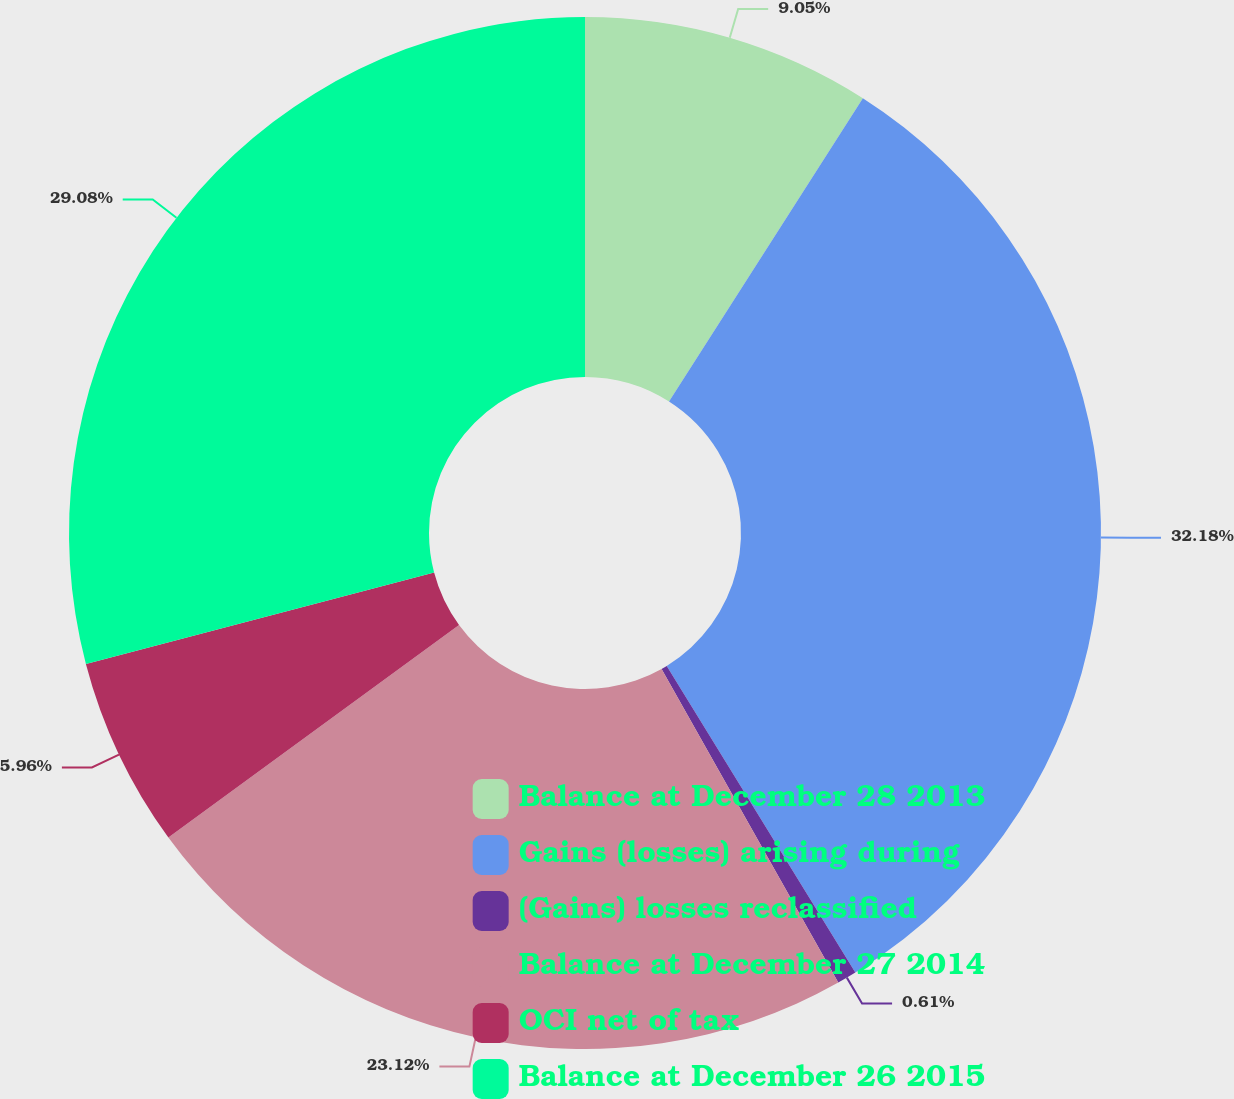Convert chart to OTSL. <chart><loc_0><loc_0><loc_500><loc_500><pie_chart><fcel>Balance at December 28 2013<fcel>Gains (losses) arising during<fcel>(Gains) losses reclassified<fcel>Balance at December 27 2014<fcel>OCI net of tax<fcel>Balance at December 26 2015<nl><fcel>9.05%<fcel>32.17%<fcel>0.61%<fcel>23.12%<fcel>5.96%<fcel>29.08%<nl></chart> 